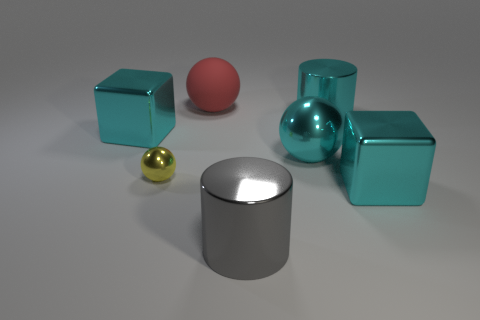Subtract all large red rubber spheres. How many spheres are left? 2 Add 1 big green metallic cylinders. How many objects exist? 8 Subtract 2 spheres. How many spheres are left? 1 Subtract all cyan cylinders. How many cylinders are left? 1 Subtract all blocks. How many objects are left? 5 Subtract 0 gray blocks. How many objects are left? 7 Subtract all yellow cylinders. Subtract all gray cubes. How many cylinders are left? 2 Subtract all red blocks. How many yellow balls are left? 1 Subtract all tiny green rubber things. Subtract all yellow metal balls. How many objects are left? 6 Add 7 big cyan metallic cubes. How many big cyan metallic cubes are left? 9 